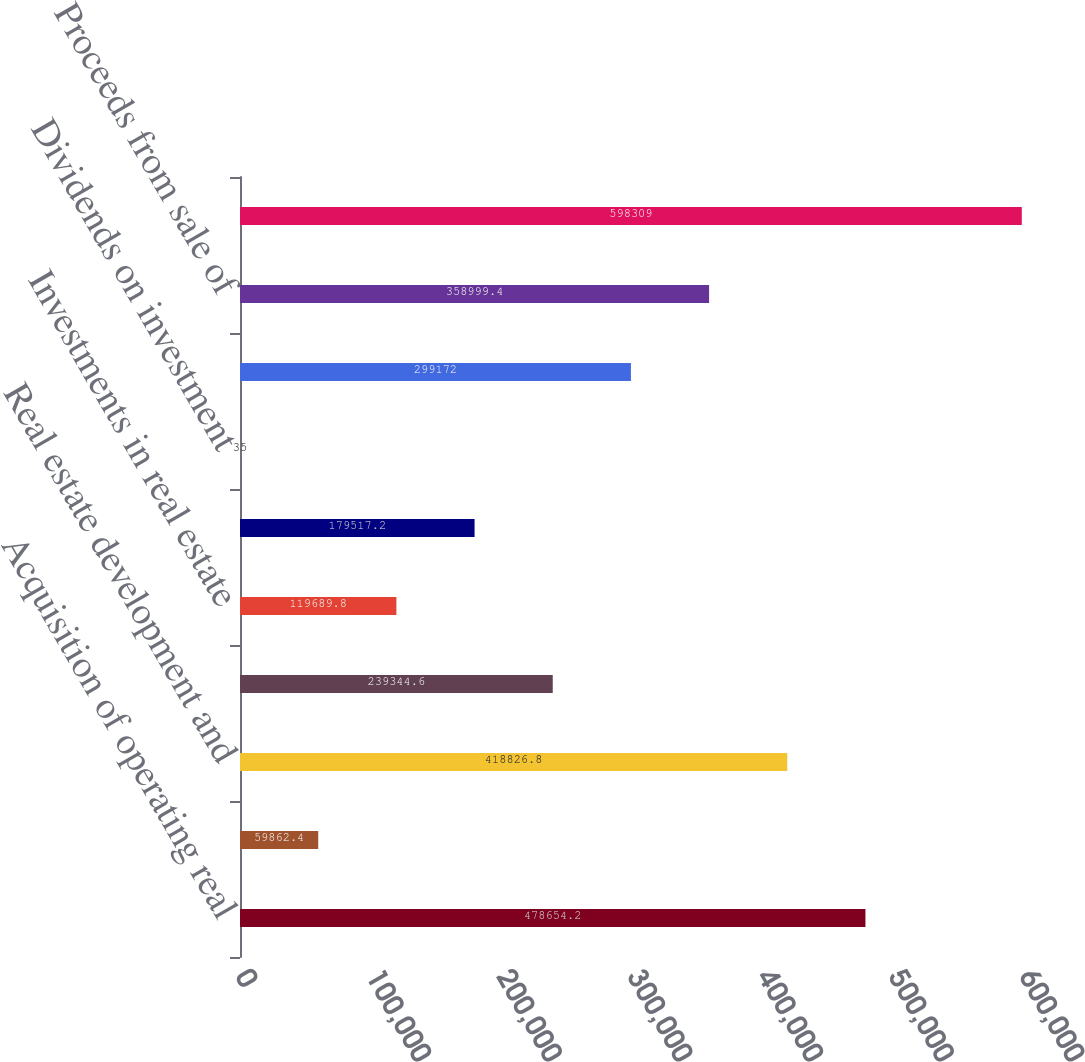Convert chart to OTSL. <chart><loc_0><loc_0><loc_500><loc_500><bar_chart><fcel>Acquisition of operating real<fcel>Costs paid in advance of real<fcel>Real estate development and<fcel>Proceeds from sale of real<fcel>Investments in real estate<fcel>Distributions received from<fcel>Dividends on investment<fcel>Acquisition of securities<fcel>Proceeds from sale of<fcel>Net cash used in investing<nl><fcel>478654<fcel>59862.4<fcel>418827<fcel>239345<fcel>119690<fcel>179517<fcel>35<fcel>299172<fcel>358999<fcel>598309<nl></chart> 